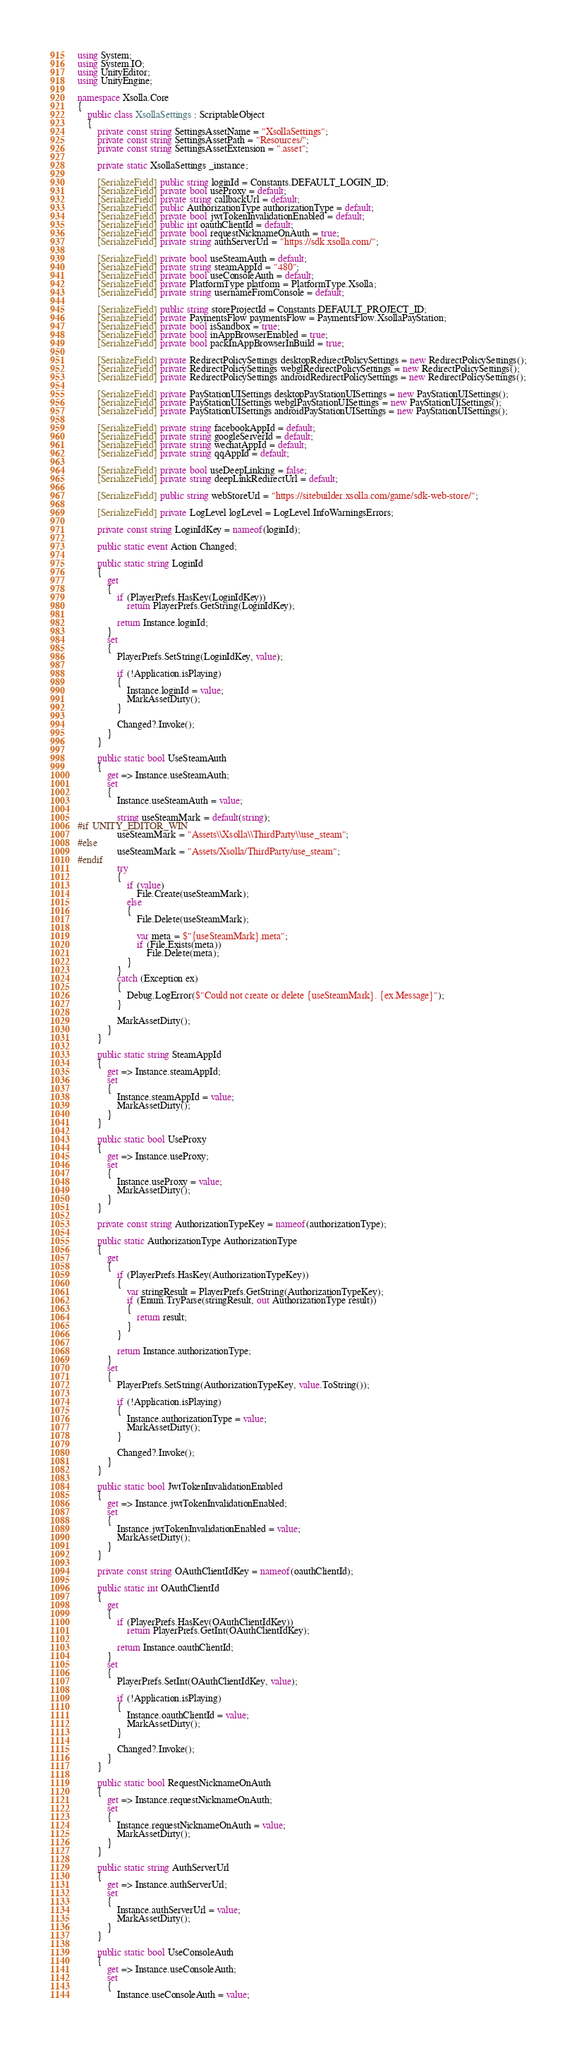<code> <loc_0><loc_0><loc_500><loc_500><_C#_>using System;
using System.IO;
using UnityEditor;
using UnityEngine;

namespace Xsolla.Core
{
	public class XsollaSettings : ScriptableObject
	{
		private const string SettingsAssetName = "XsollaSettings";
		private const string SettingsAssetPath = "Resources/";
		private const string SettingsAssetExtension = ".asset";

		private static XsollaSettings _instance;

		[SerializeField] public string loginId = Constants.DEFAULT_LOGIN_ID;
		[SerializeField] private bool useProxy = default;
		[SerializeField] private string callbackUrl = default;
		[SerializeField] public AuthorizationType authorizationType = default;
		[SerializeField] private bool jwtTokenInvalidationEnabled = default;
		[SerializeField] public int oauthClientId = default;
		[SerializeField] private bool requestNicknameOnAuth = true;
		[SerializeField] private string authServerUrl = "https://sdk.xsolla.com/";

		[SerializeField] private bool useSteamAuth = default;
		[SerializeField] private string steamAppId = "480";
		[SerializeField] private bool useConsoleAuth = default;
		[SerializeField] private PlatformType platform = PlatformType.Xsolla;
		[SerializeField] private string usernameFromConsole = default;

		[SerializeField] public string storeProjectId = Constants.DEFAULT_PROJECT_ID;
		[SerializeField] private PaymentsFlow paymentsFlow = PaymentsFlow.XsollaPayStation;
		[SerializeField] private bool isSandbox = true;
		[SerializeField] private bool inAppBrowserEnabled = true;
		[SerializeField] private bool packInAppBrowserInBuild = true;

		[SerializeField] private RedirectPolicySettings desktopRedirectPolicySettings = new RedirectPolicySettings();
		[SerializeField] private RedirectPolicySettings webglRedirectPolicySettings = new RedirectPolicySettings();
		[SerializeField] private RedirectPolicySettings androidRedirectPolicySettings = new RedirectPolicySettings();

		[SerializeField] private PayStationUISettings desktopPayStationUISettings = new PayStationUISettings();
		[SerializeField] private PayStationUISettings webglPayStationUISettings = new PayStationUISettings();
		[SerializeField] private PayStationUISettings androidPayStationUISettings = new PayStationUISettings();

		[SerializeField] private string facebookAppId = default;
		[SerializeField] private string googleServerId = default;
		[SerializeField] private string wechatAppId = default;
		[SerializeField] private string qqAppId = default;

		[SerializeField] private bool useDeepLinking = false;
		[SerializeField] private string deepLinkRedirectUrl = default;

		[SerializeField] public string webStoreUrl = "https://sitebuilder.xsolla.com/game/sdk-web-store/";

		[SerializeField] private LogLevel logLevel = LogLevel.InfoWarningsErrors;
		
		private const string LoginIdKey = nameof(loginId);

		public static event Action Changed;

		public static string LoginId
		{
			get
			{
				if (PlayerPrefs.HasKey(LoginIdKey))
					return PlayerPrefs.GetString(LoginIdKey);

				return Instance.loginId;
			}
			set
			{
				PlayerPrefs.SetString(LoginIdKey, value);

				if (!Application.isPlaying)
				{
					Instance.loginId = value;
					MarkAssetDirty();
				}
				
				Changed?.Invoke();
			}
		}

		public static bool UseSteamAuth
		{
			get => Instance.useSteamAuth;
			set
			{
				Instance.useSteamAuth = value;

				string useSteamMark = default(string);
#if UNITY_EDITOR_WIN
				useSteamMark = "Assets\\Xsolla\\ThirdParty\\use_steam";
#else
				useSteamMark = "Assets/Xsolla/ThirdParty/use_steam";
#endif
				try
				{
					if (value)
						File.Create(useSteamMark);
					else
					{
						File.Delete(useSteamMark);

						var meta = $"{useSteamMark}.meta";
						if (File.Exists(meta))
							File.Delete(meta);
					}
				}
				catch (Exception ex)
				{
					Debug.LogError($"Could not create or delete {useSteamMark}. {ex.Message}");
				}

				MarkAssetDirty();
			}
		}

		public static string SteamAppId
		{
			get => Instance.steamAppId;
			set
			{
				Instance.steamAppId = value;
				MarkAssetDirty();
			}
		}

		public static bool UseProxy
		{
			get => Instance.useProxy;
			set
			{
				Instance.useProxy = value;
				MarkAssetDirty();
			}
		}

		private const string AuthorizationTypeKey = nameof(authorizationType);

		public static AuthorizationType AuthorizationType
		{
			get
			{
				if (PlayerPrefs.HasKey(AuthorizationTypeKey))
				{
					var stringResult = PlayerPrefs.GetString(AuthorizationTypeKey);
					if (Enum.TryParse(stringResult, out AuthorizationType result))
					{
						return result;
					}
				}

				return Instance.authorizationType;
			}
			set
			{
				PlayerPrefs.SetString(AuthorizationTypeKey, value.ToString());
				
				if (!Application.isPlaying)
				{
					Instance.authorizationType = value;
					MarkAssetDirty();
				}
				
				Changed?.Invoke();
			}
		}

		public static bool JwtTokenInvalidationEnabled
		{
			get => Instance.jwtTokenInvalidationEnabled;
			set
			{
				Instance.jwtTokenInvalidationEnabled = value;
				MarkAssetDirty();
			}
		}

		private const string OAuthClientIdKey = nameof(oauthClientId);

		public static int OAuthClientId
		{
			get
			{
				if (PlayerPrefs.HasKey(OAuthClientIdKey))
					return PlayerPrefs.GetInt(OAuthClientIdKey);

				return Instance.oauthClientId;
			}
			set
			{
				PlayerPrefs.SetInt(OAuthClientIdKey, value);

				if (!Application.isPlaying)
				{
					Instance.oauthClientId = value;
					MarkAssetDirty();
				}
				
				Changed?.Invoke();
			}
		}

		public static bool RequestNicknameOnAuth
		{
			get => Instance.requestNicknameOnAuth;
			set
			{
				Instance.requestNicknameOnAuth = value;
				MarkAssetDirty();
			}
		}

		public static string AuthServerUrl
		{
			get => Instance.authServerUrl;
			set
			{
				Instance.authServerUrl = value;
				MarkAssetDirty();
			}
		}

		public static bool UseConsoleAuth
		{
			get => Instance.useConsoleAuth;
			set
			{
				Instance.useConsoleAuth = value;</code> 